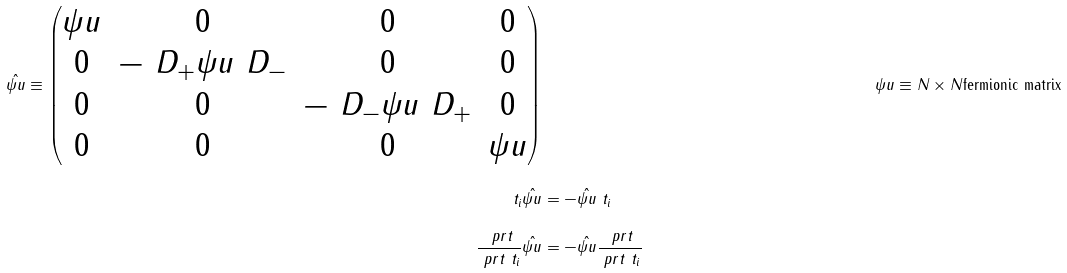<formula> <loc_0><loc_0><loc_500><loc_500>\hat { \psi u } \equiv \begin{pmatrix} \psi u & 0 & 0 & 0 \\ 0 & - \ D _ { + } \psi u \ D _ { - } & 0 & 0 \\ 0 & 0 & - \ D _ { - } \psi u \ D _ { + } & 0 \\ 0 & 0 & 0 & \psi u \end{pmatrix} & & \psi u & \equiv N \times N \text {fermionic matrix} \\ \ t _ { i } \hat { \psi u } & = - \hat { \psi u } \ t _ { i } \\ \frac { \ p r t } { \ p r t \ t _ { i } } \hat { \psi u } & = - \hat { \psi u } \frac { \ p r t } { \ p r t \ t _ { i } }</formula> 